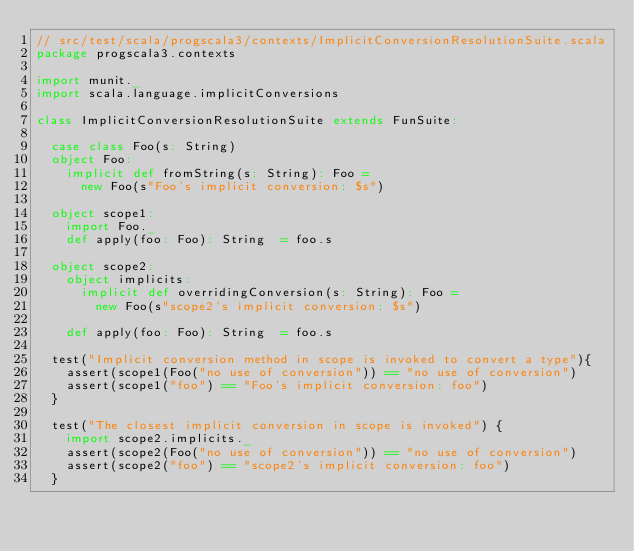Convert code to text. <code><loc_0><loc_0><loc_500><loc_500><_Scala_>// src/test/scala/progscala3/contexts/ImplicitConversionResolutionSuite.scala
package progscala3.contexts

import munit._
import scala.language.implicitConversions

class ImplicitConversionResolutionSuite extends FunSuite:

  case class Foo(s: String)
  object Foo:
    implicit def fromString(s: String): Foo =
      new Foo(s"Foo's implicit conversion: $s")

  object scope1:
    import Foo._
    def apply(foo: Foo): String  = foo.s

  object scope2:
    object implicits:
      implicit def overridingConversion(s: String): Foo =
        new Foo(s"scope2's implicit conversion: $s")

    def apply(foo: Foo): String  = foo.s

  test("Implicit conversion method in scope is invoked to convert a type"){
    assert(scope1(Foo("no use of conversion")) == "no use of conversion")
    assert(scope1("foo") == "Foo's implicit conversion: foo")
  }

  test("The closest implicit conversion in scope is invoked") {
    import scope2.implicits._
    assert(scope2(Foo("no use of conversion")) == "no use of conversion")
    assert(scope2("foo") == "scope2's implicit conversion: foo")
  }
</code> 